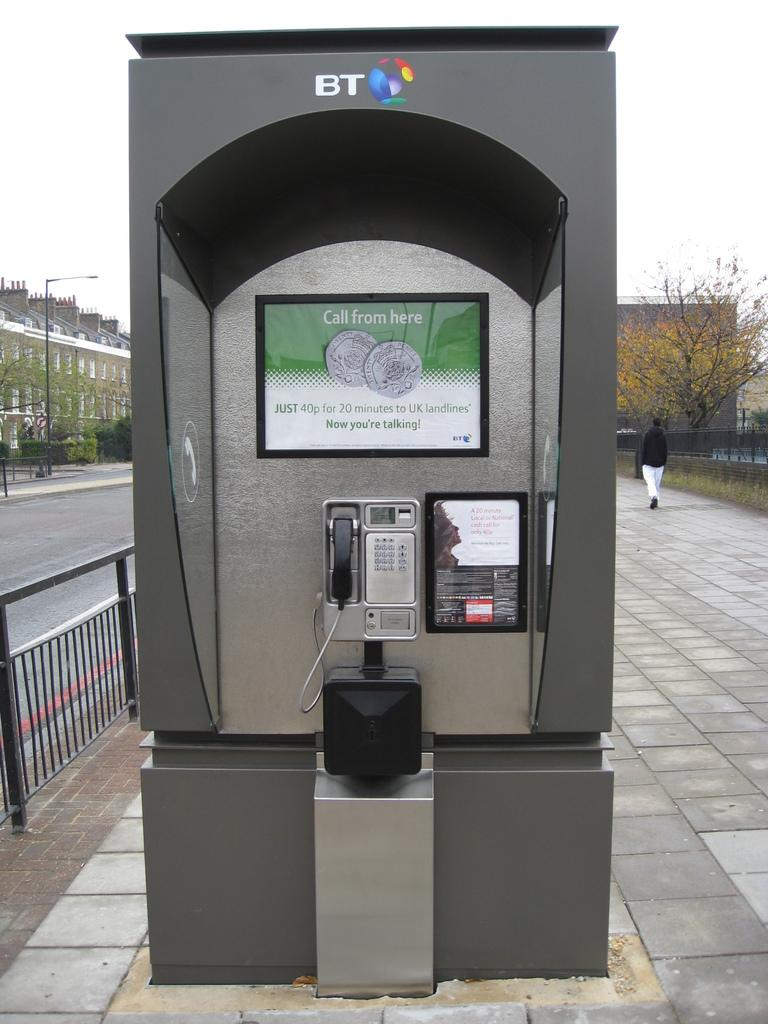<image>
Summarize the visual content of the image. A BT payphone advertising phone calls for just 40p. 